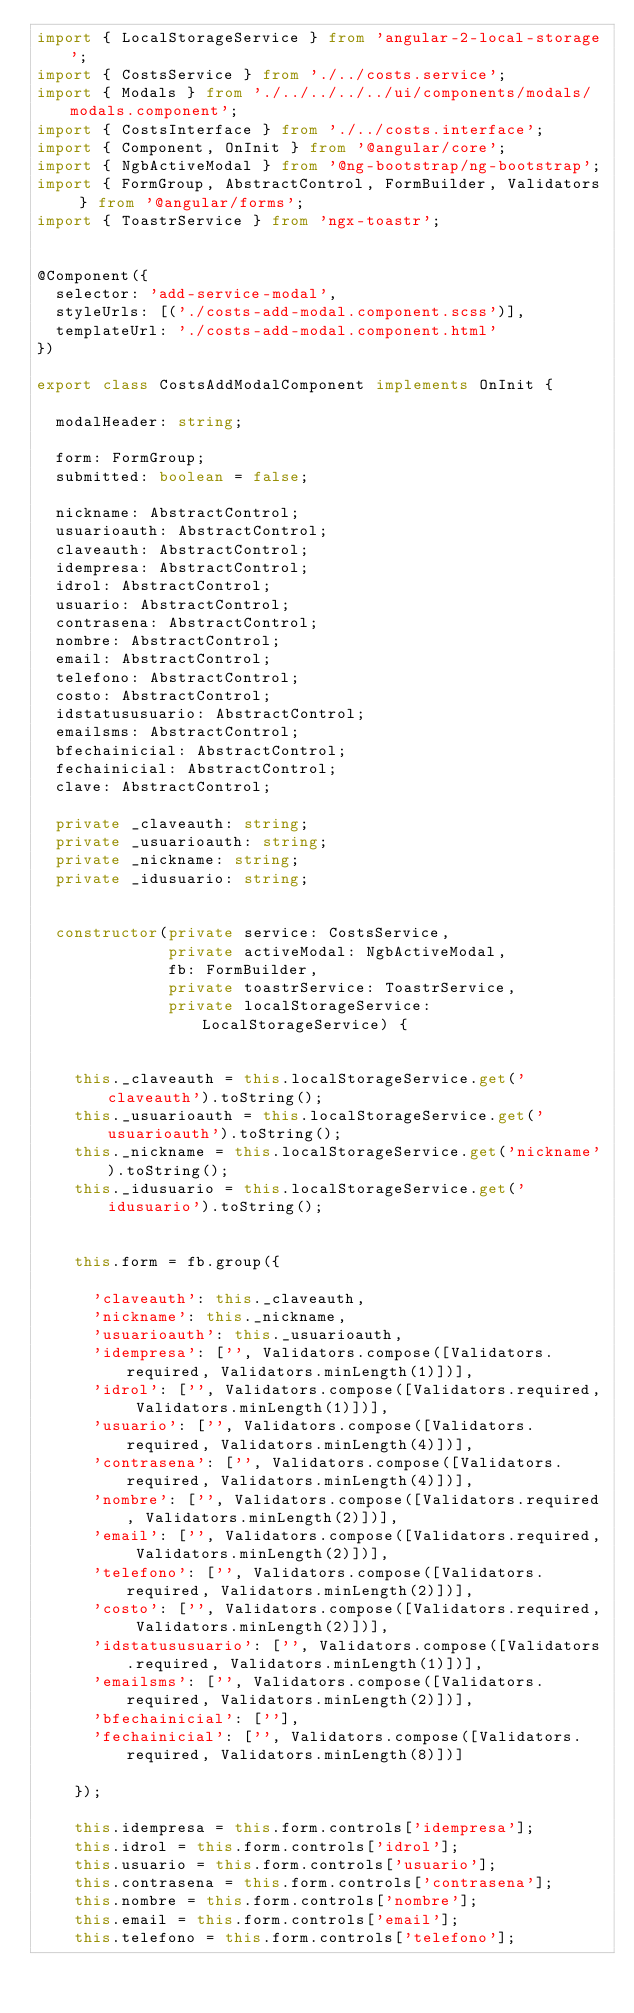<code> <loc_0><loc_0><loc_500><loc_500><_TypeScript_>import { LocalStorageService } from 'angular-2-local-storage';
import { CostsService } from './../costs.service';
import { Modals } from './../../../../ui/components/modals/modals.component';
import { CostsInterface } from './../costs.interface';
import { Component, OnInit } from '@angular/core';
import { NgbActiveModal } from '@ng-bootstrap/ng-bootstrap';
import { FormGroup, AbstractControl, FormBuilder, Validators } from '@angular/forms';
import { ToastrService } from 'ngx-toastr';


@Component({
  selector: 'add-service-modal',
  styleUrls: [('./costs-add-modal.component.scss')],
  templateUrl: './costs-add-modal.component.html'
})

export class CostsAddModalComponent implements OnInit {

  modalHeader: string;

  form: FormGroup;
  submitted: boolean = false;

  nickname: AbstractControl;
  usuarioauth: AbstractControl;
  claveauth: AbstractControl;
  idempresa: AbstractControl;
  idrol: AbstractControl;
  usuario: AbstractControl;
  contrasena: AbstractControl;
  nombre: AbstractControl;
  email: AbstractControl;
  telefono: AbstractControl;
  costo: AbstractControl;
  idstatususuario: AbstractControl;
  emailsms: AbstractControl;
  bfechainicial: AbstractControl;
  fechainicial: AbstractControl;
  clave: AbstractControl;

  private _claveauth: string;
  private _usuarioauth: string;
  private _nickname: string;
  private _idusuario: string;


  constructor(private service: CostsService,
              private activeModal: NgbActiveModal,
              fb: FormBuilder,
              private toastrService: ToastrService,
              private localStorageService: LocalStorageService) {


    this._claveauth = this.localStorageService.get('claveauth').toString();
    this._usuarioauth = this.localStorageService.get('usuarioauth').toString();
    this._nickname = this.localStorageService.get('nickname').toString();
    this._idusuario = this.localStorageService.get('idusuario').toString();
 

    this.form = fb.group({

      'claveauth': this._claveauth,
      'nickname': this._nickname,
      'usuarioauth': this._usuarioauth,
      'idempresa': ['', Validators.compose([Validators.required, Validators.minLength(1)])],
      'idrol': ['', Validators.compose([Validators.required, Validators.minLength(1)])],
      'usuario': ['', Validators.compose([Validators.required, Validators.minLength(4)])],
      'contrasena': ['', Validators.compose([Validators.required, Validators.minLength(4)])],
      'nombre': ['', Validators.compose([Validators.required, Validators.minLength(2)])],
      'email': ['', Validators.compose([Validators.required, Validators.minLength(2)])],
      'telefono': ['', Validators.compose([Validators.required, Validators.minLength(2)])],
      'costo': ['', Validators.compose([Validators.required, Validators.minLength(2)])],
      'idstatususuario': ['', Validators.compose([Validators.required, Validators.minLength(1)])],
      'emailsms': ['', Validators.compose([Validators.required, Validators.minLength(2)])],
      'bfechainicial': [''],
      'fechainicial': ['', Validators.compose([Validators.required, Validators.minLength(8)])]

    });

    this.idempresa = this.form.controls['idempresa'];
    this.idrol = this.form.controls['idrol'];
    this.usuario = this.form.controls['usuario'];
    this.contrasena = this.form.controls['contrasena'];
    this.nombre = this.form.controls['nombre'];
    this.email = this.form.controls['email'];
    this.telefono = this.form.controls['telefono'];</code> 